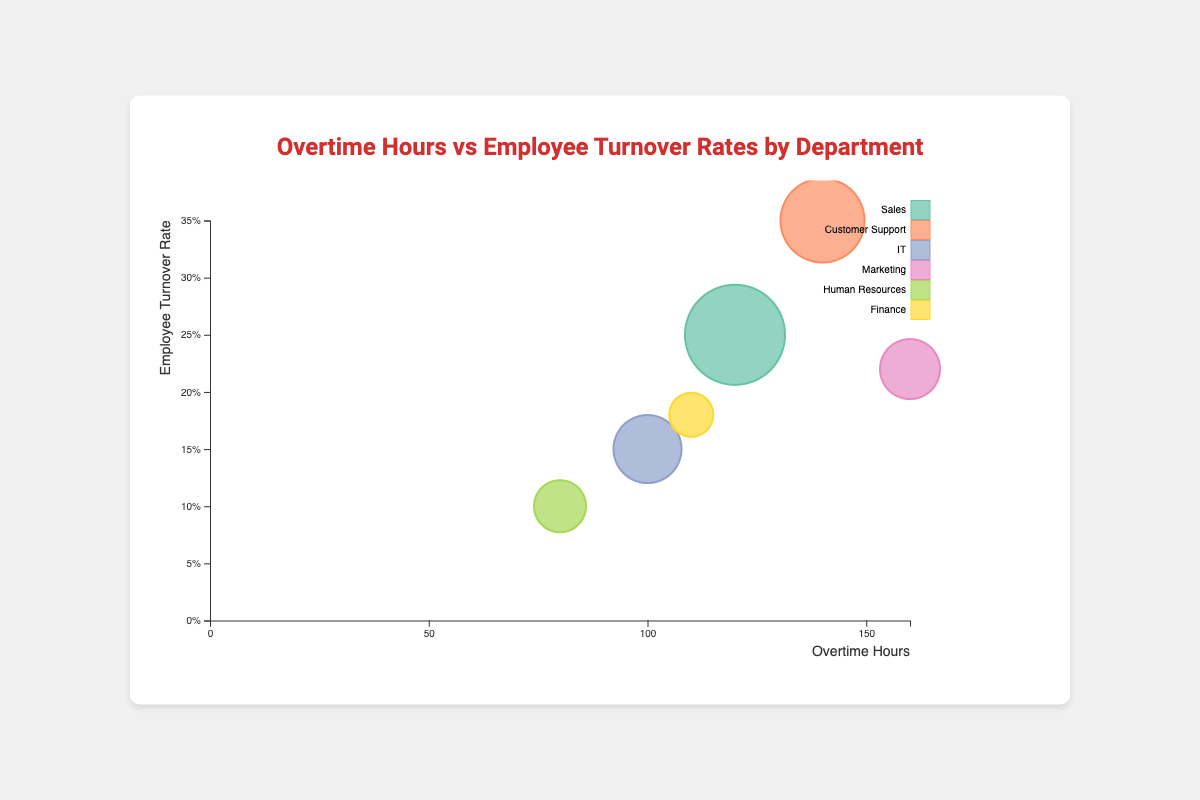How many departments are represented in the bubble chart? By counting the number of distinct bubbles (each representing a department with a unique color), you can see there are six.
Answer: Six Which department has the highest overtime hours? By looking at the x-axis (overtime hours) and finding the bubble furthest to the right, the highest value is for Marketing with 160 overtime hours.
Answer: Marketing What is the relationship between the number of employees and the size of the bubbles? The size of the bubbles is directly proportional to the number of employees in each department. This can be inferred from the varying bubble sizes.
Answer: Larger bubbles represent more employees Which department has the lowest employee turnover rate? By examining the y-axis (turnover rate) and identifying the bubble closest to the bottom axis, Human Resources has the lowest turnover rate of 0.10.
Answer: Human Resources How does the turnover rate of the Sales department compare to the Customer Support department? The Sales department has a turnover rate of 0.25, while the Customer Support department has a higher turnover rate of 0.35.
Answer: Customer Support has a higher rate What is the combined turnover rate for the IT and Finance departments? Summing the turnover rates of IT (0.15) and Finance (0.18), we get 0.15 + 0.18 = 0.33.
Answer: 0.33 Which department has the second fewest overtime hours, and what is the overtime value? By sorting the bubble positions on the x-axis from left to right, the department with the second fewest overtime hours is Finance with 110 hours.
Answer: Finance, 110 hours Are there any departments where both overtime hours and turnover rates are above the median values for all departments? Median overtime hours are around 115 (average of 110 and 120); median turnover rate is 0.195. Sales and Customer Support both fit these criteria.
Answer: Sales, Customer Support What is the bubble color for the IT department? The visual indication from the legend shows IT represented in a specific color, for instance, purple (if the color matches this description).
Answer: Purple (or matching color) How does the size of the Finance department's bubble compare to the Human Resources department's bubble? The bubble for Human Resources represents 20 employees, while for Finance it represents 15 employees. Therefore, the Human Resources bubble is larger.
Answer: Human Resources' bubble is larger 